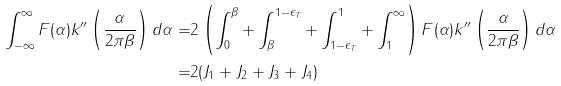<formula> <loc_0><loc_0><loc_500><loc_500>\int _ { - \infty } ^ { \infty } F ( \alpha ) k ^ { \prime \prime } \left ( \frac { \alpha } { 2 \pi \beta } \right ) d \alpha = & 2 \left ( \int _ { 0 } ^ { \beta } + \int _ { \beta } ^ { 1 - \epsilon _ { T } } + \int _ { 1 - \epsilon _ { T } } ^ { 1 } + \int _ { 1 } ^ { \infty } \right ) F ( \alpha ) k ^ { \prime \prime } \left ( \frac { \alpha } { 2 \pi \beta } \right ) d \alpha \\ = & 2 ( J _ { 1 } + J _ { 2 } + J _ { 3 } + J _ { 4 } )</formula> 